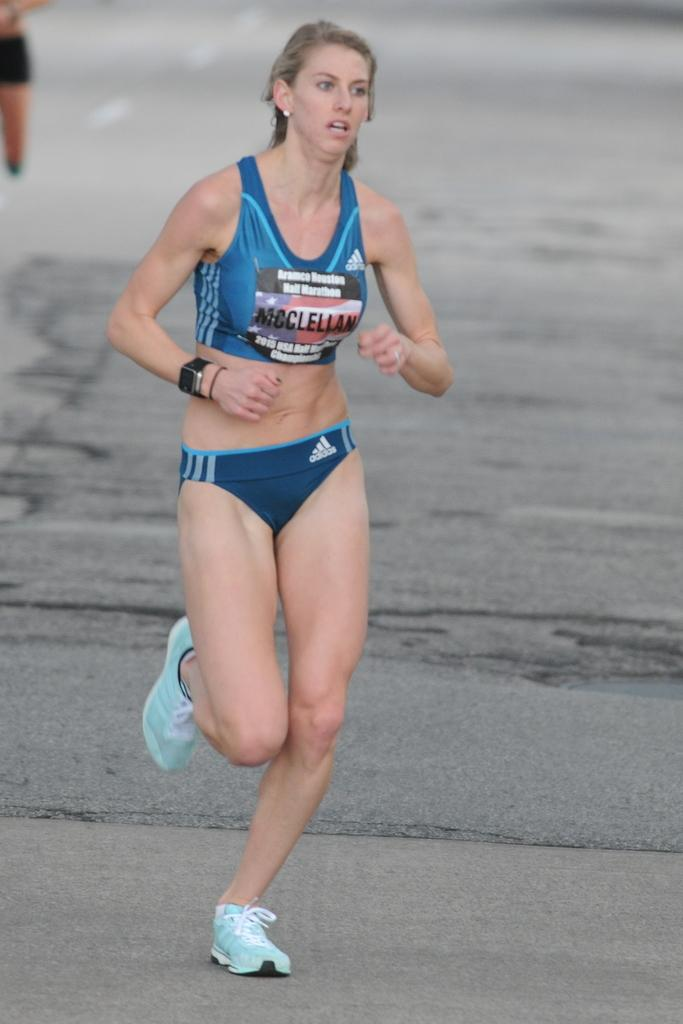<image>
Summarize the visual content of the image. A woman running who is wearing the tag McClellan. 